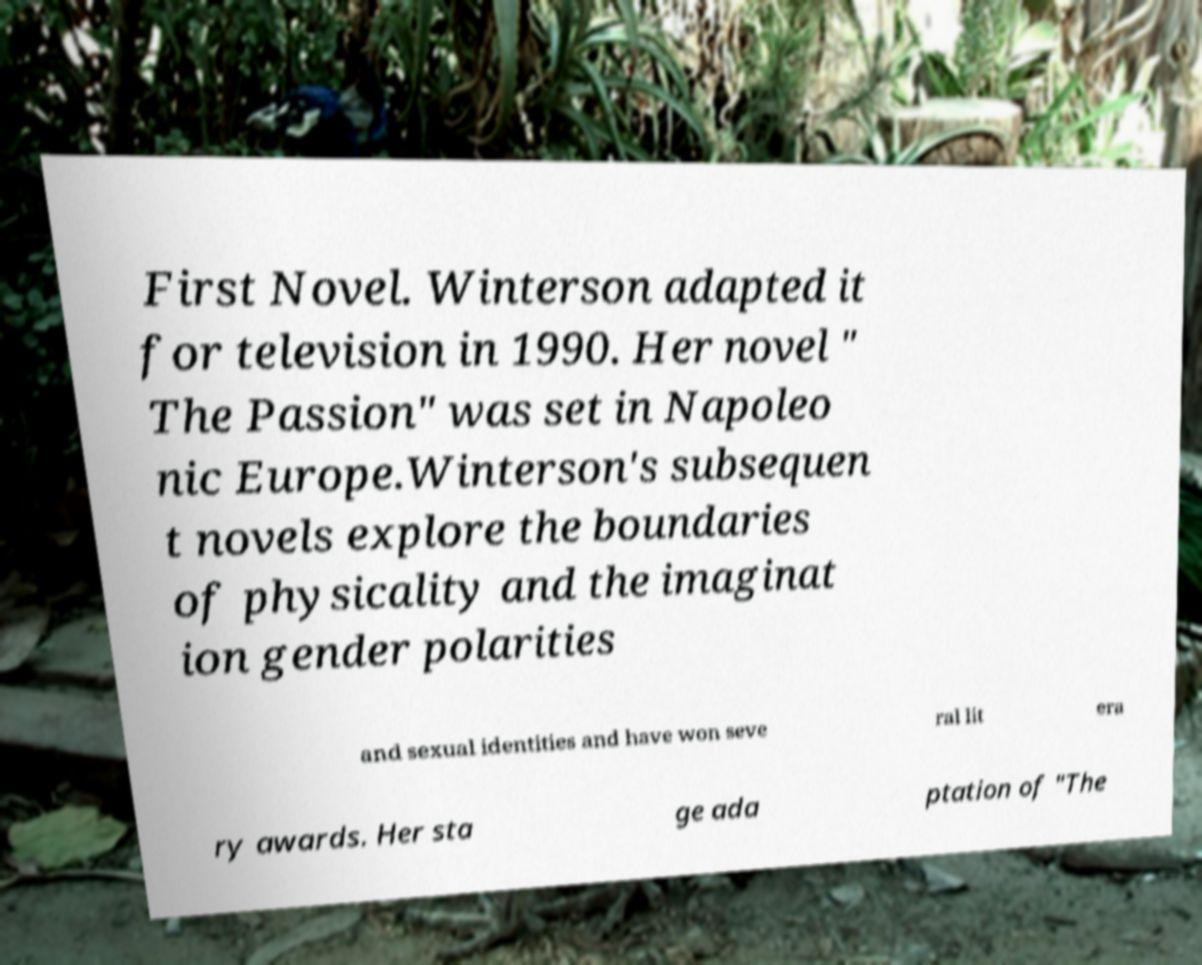Could you extract and type out the text from this image? First Novel. Winterson adapted it for television in 1990. Her novel " The Passion" was set in Napoleo nic Europe.Winterson's subsequen t novels explore the boundaries of physicality and the imaginat ion gender polarities and sexual identities and have won seve ral lit era ry awards. Her sta ge ada ptation of "The 